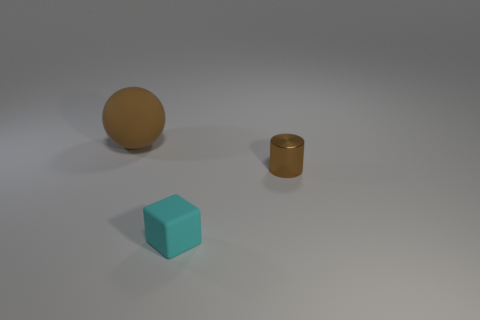How many small shiny cylinders are the same color as the rubber sphere?
Provide a short and direct response. 1. Are there any other things that are made of the same material as the brown cylinder?
Give a very brief answer. No. What number of other things are there of the same shape as the cyan object?
Make the answer very short. 0. Is the metallic thing the same shape as the small cyan matte thing?
Keep it short and to the point. No. What number of objects are things that are in front of the brown metallic cylinder or brown objects right of the tiny cyan cube?
Provide a succinct answer. 2. How many objects are either matte blocks or brown shiny cylinders?
Give a very brief answer. 2. What number of small blocks are to the left of the rubber object in front of the brown rubber thing?
Your answer should be compact. 0. What number of other objects are the same size as the cyan rubber block?
Give a very brief answer. 1. There is a cylinder that is the same color as the large object; what size is it?
Your answer should be compact. Small. There is a brown thing that is to the left of the cyan rubber cube; what material is it?
Provide a short and direct response. Rubber. 